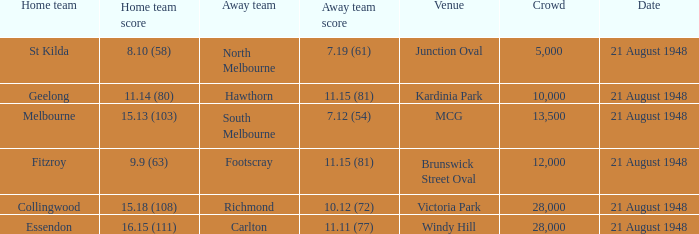Could you parse the entire table as a dict? {'header': ['Home team', 'Home team score', 'Away team', 'Away team score', 'Venue', 'Crowd', 'Date'], 'rows': [['St Kilda', '8.10 (58)', 'North Melbourne', '7.19 (61)', 'Junction Oval', '5,000', '21 August 1948'], ['Geelong', '11.14 (80)', 'Hawthorn', '11.15 (81)', 'Kardinia Park', '10,000', '21 August 1948'], ['Melbourne', '15.13 (103)', 'South Melbourne', '7.12 (54)', 'MCG', '13,500', '21 August 1948'], ['Fitzroy', '9.9 (63)', 'Footscray', '11.15 (81)', 'Brunswick Street Oval', '12,000', '21 August 1948'], ['Collingwood', '15.18 (108)', 'Richmond', '10.12 (72)', 'Victoria Park', '28,000', '21 August 1948'], ['Essendon', '16.15 (111)', 'Carlton', '11.11 (77)', 'Windy Hill', '28,000', '21 August 1948']]} If the Away team is north melbourne, what's the Home team score? 8.10 (58). 